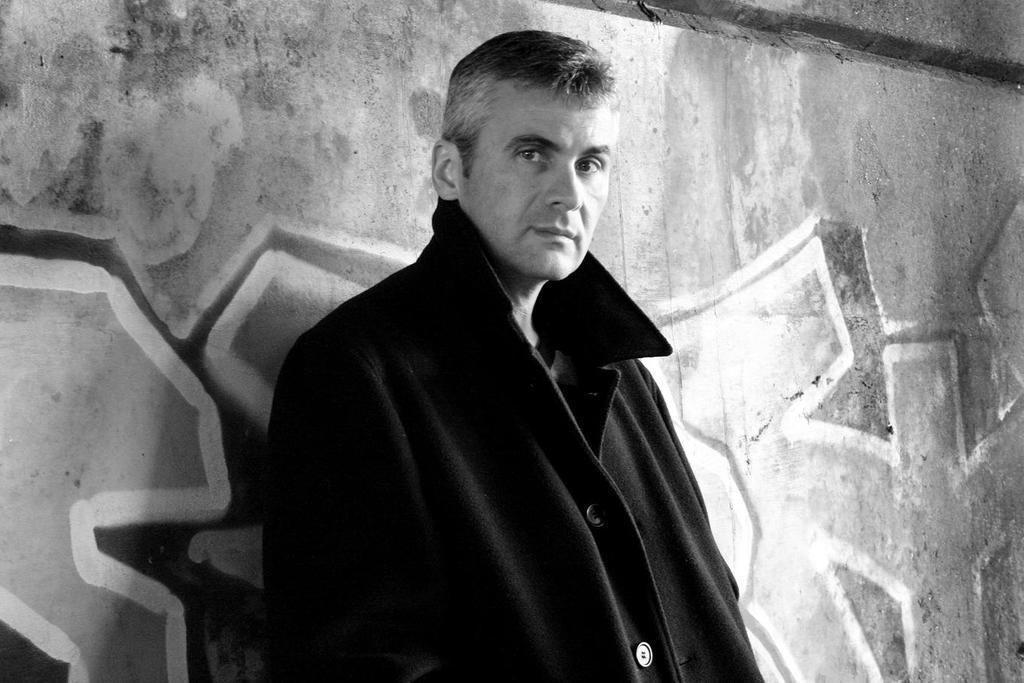In one or two sentences, can you explain what this image depicts? In this image we can see this person wearing black jacket is standing near the wall. In the background, we can see graffiti on the wall. 